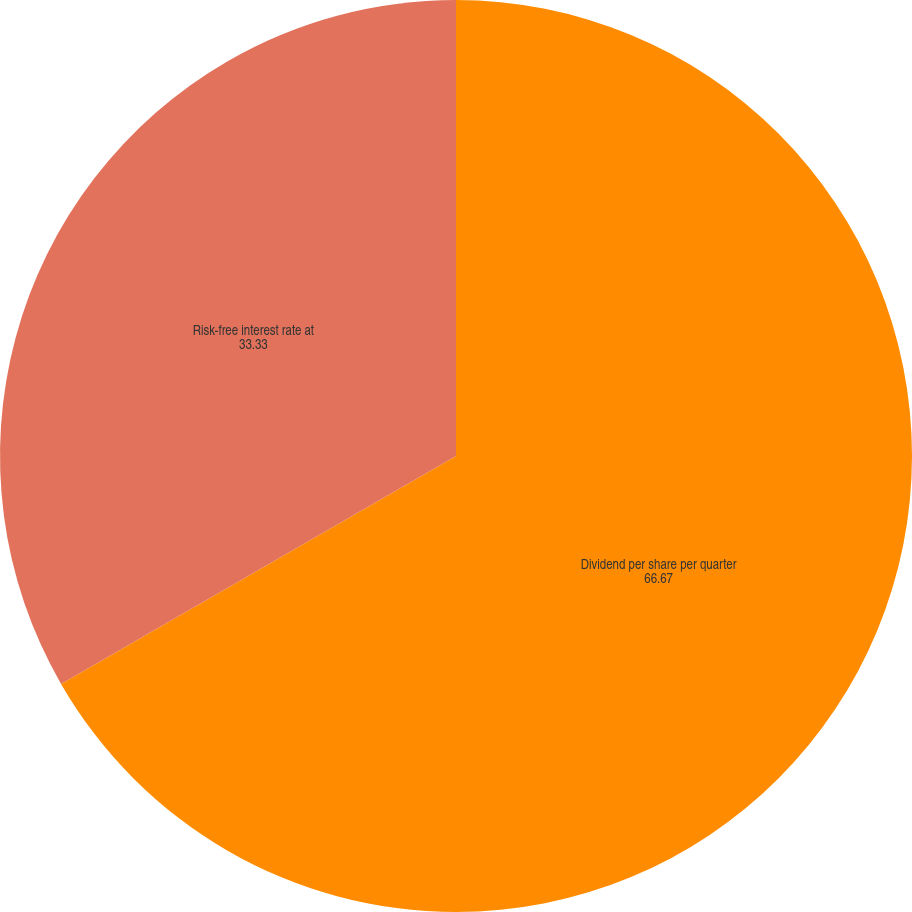Convert chart. <chart><loc_0><loc_0><loc_500><loc_500><pie_chart><fcel>Dividend per share per quarter<fcel>Risk-free interest rate at<nl><fcel>66.67%<fcel>33.33%<nl></chart> 